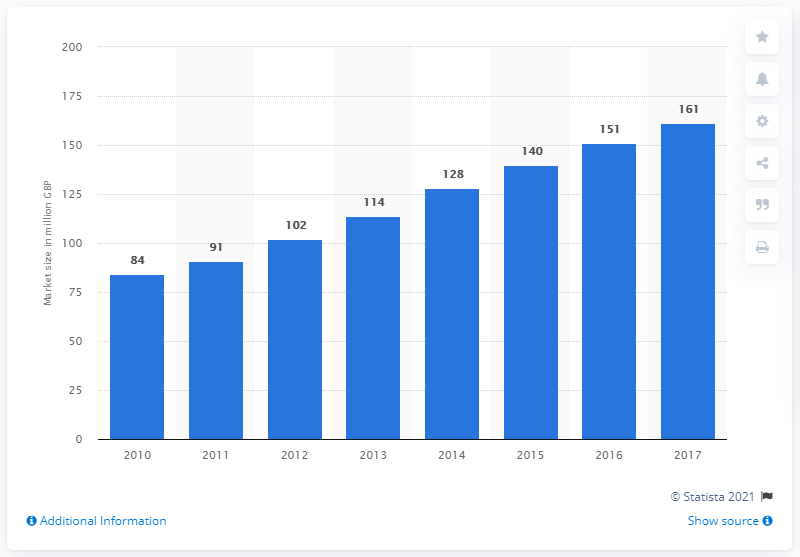Outline some significant characteristics in this image. In the United Kingdom, the management consultancy segment has not been analyzed by IT product and service type since 2010. The management consultancy segment of the cyber security market was estimated to be 161... in 2017. 